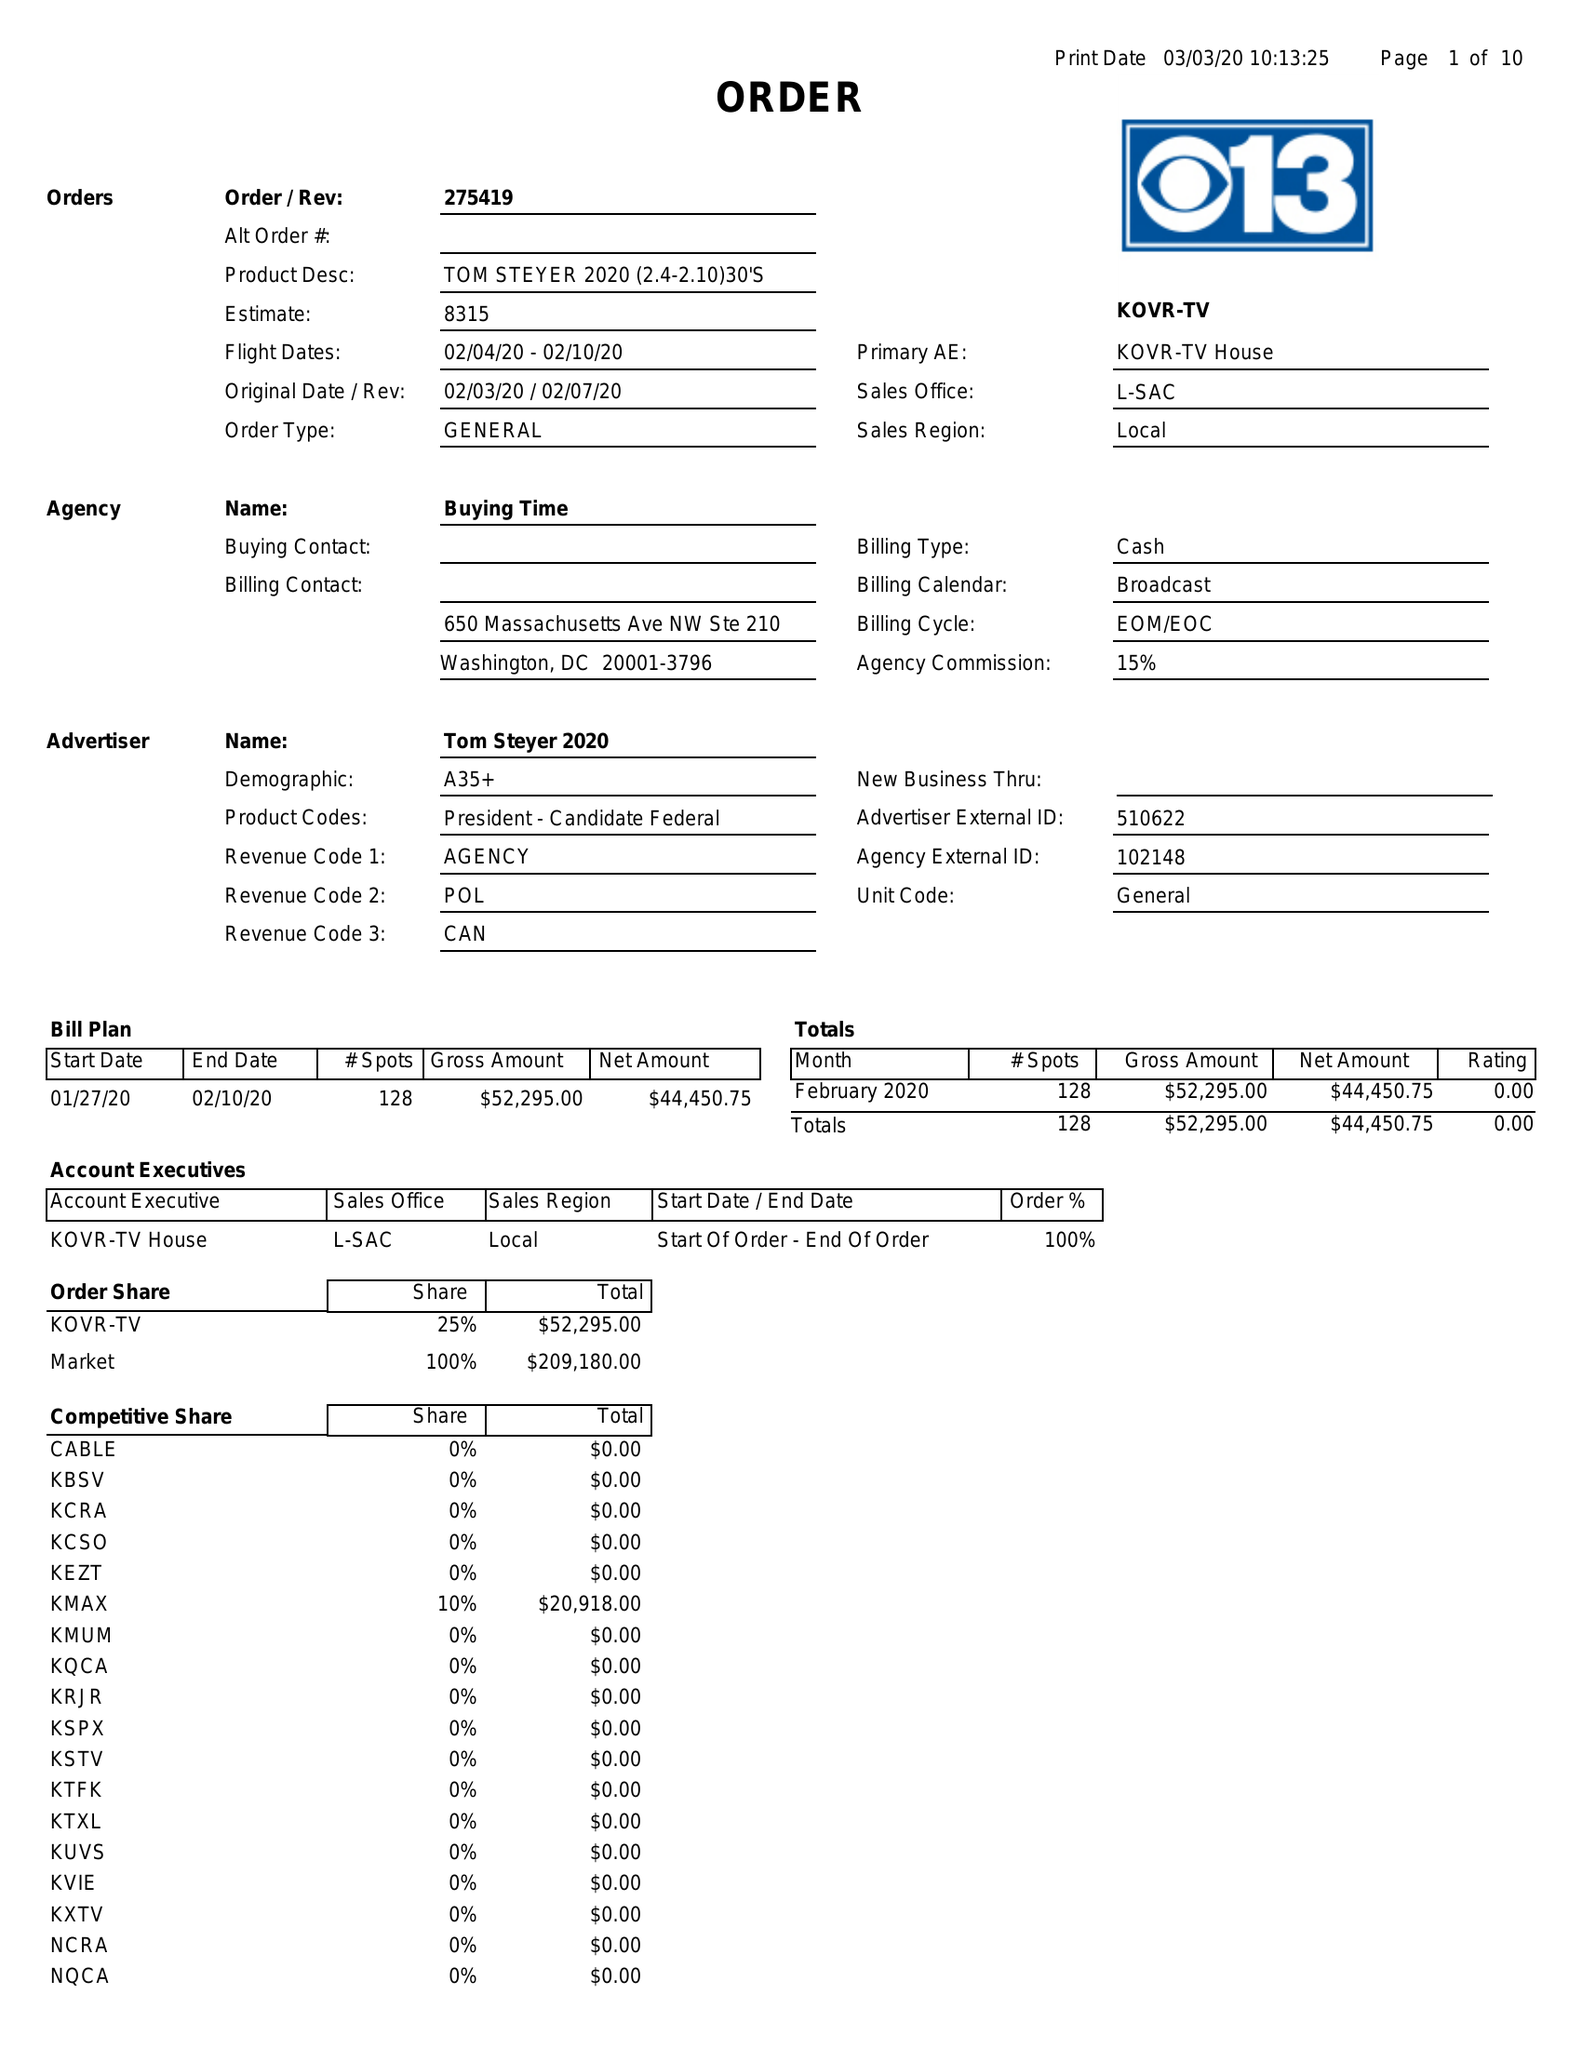What is the value for the advertiser?
Answer the question using a single word or phrase. TOM STEYER 2020 